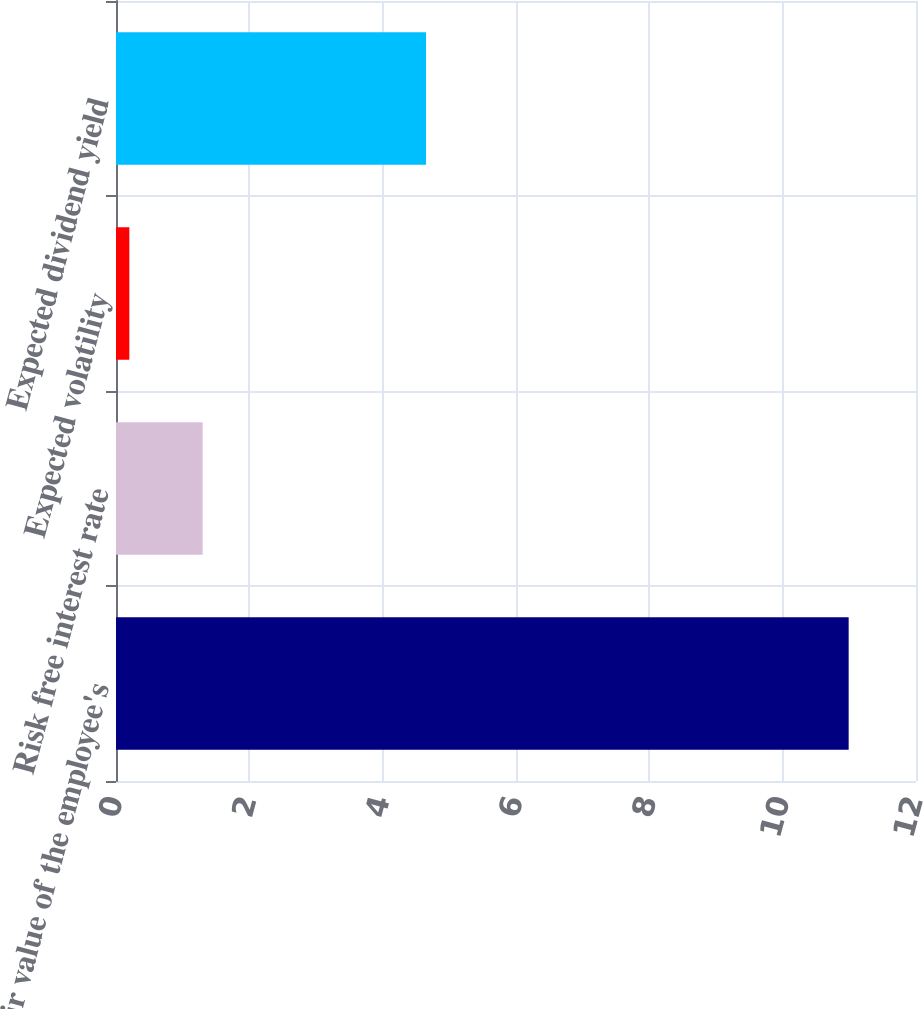Convert chart. <chart><loc_0><loc_0><loc_500><loc_500><bar_chart><fcel>Fair value of the employee's<fcel>Risk free interest rate<fcel>Expected volatility<fcel>Expected dividend yield<nl><fcel>10.99<fcel>1.3<fcel>0.2<fcel>4.65<nl></chart> 